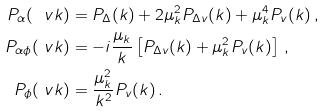Convert formula to latex. <formula><loc_0><loc_0><loc_500><loc_500>P _ { \alpha } ( \ v k ) & = P _ { \Delta } ( k ) + 2 \mu _ { k } ^ { 2 } P _ { \Delta v } ( k ) + \mu _ { k } ^ { 4 } P _ { v } ( k ) \, , \\ P _ { \alpha \phi } ( \ v k ) & = - i \frac { \mu _ { k } } { k } \left [ P _ { \Delta v } ( k ) + \mu _ { k } ^ { 2 } P _ { v } ( k ) \right ] \, , \\ P _ { \phi } ( \ v k ) & = \frac { \mu _ { k } ^ { 2 } } { k ^ { 2 } } P _ { v } ( k ) \, .</formula> 